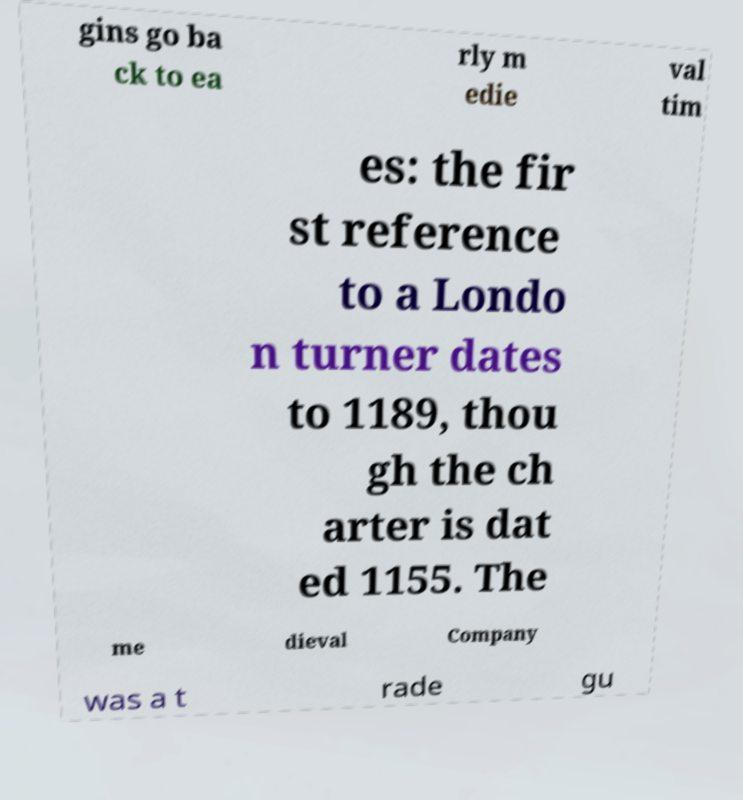I need the written content from this picture converted into text. Can you do that? gins go ba ck to ea rly m edie val tim es: the fir st reference to a Londo n turner dates to 1189, thou gh the ch arter is dat ed 1155. The me dieval Company was a t rade gu 